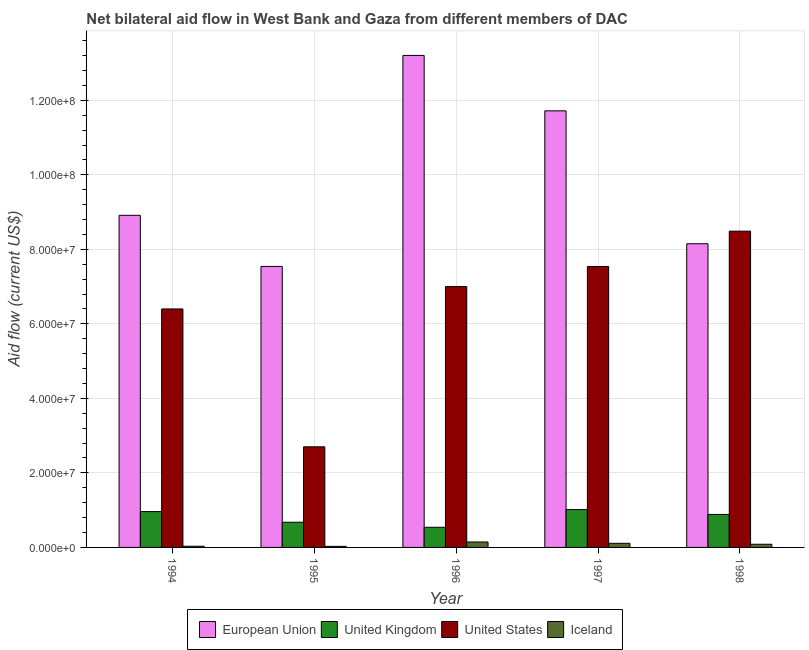How many different coloured bars are there?
Provide a succinct answer. 4. Are the number of bars per tick equal to the number of legend labels?
Keep it short and to the point. Yes. How many bars are there on the 1st tick from the right?
Provide a succinct answer. 4. In how many cases, is the number of bars for a given year not equal to the number of legend labels?
Offer a terse response. 0. What is the amount of aid given by iceland in 1996?
Provide a succinct answer. 1.46e+06. Across all years, what is the maximum amount of aid given by us?
Provide a short and direct response. 8.49e+07. Across all years, what is the minimum amount of aid given by us?
Offer a terse response. 2.70e+07. In which year was the amount of aid given by eu maximum?
Offer a terse response. 1996. In which year was the amount of aid given by us minimum?
Your answer should be very brief. 1995. What is the total amount of aid given by iceland in the graph?
Your response must be concise. 4.02e+06. What is the difference between the amount of aid given by eu in 1996 and that in 1998?
Your answer should be compact. 5.05e+07. What is the difference between the amount of aid given by uk in 1997 and the amount of aid given by us in 1994?
Your answer should be very brief. 5.40e+05. What is the average amount of aid given by eu per year?
Give a very brief answer. 9.90e+07. In the year 1994, what is the difference between the amount of aid given by uk and amount of aid given by iceland?
Provide a succinct answer. 0. What is the ratio of the amount of aid given by uk in 1994 to that in 1997?
Offer a terse response. 0.95. What is the difference between the highest and the second highest amount of aid given by eu?
Your answer should be very brief. 1.49e+07. What is the difference between the highest and the lowest amount of aid given by iceland?
Provide a short and direct response. 1.17e+06. In how many years, is the amount of aid given by us greater than the average amount of aid given by us taken over all years?
Provide a succinct answer. 3. Is it the case that in every year, the sum of the amount of aid given by us and amount of aid given by eu is greater than the sum of amount of aid given by iceland and amount of aid given by uk?
Offer a terse response. Yes. What does the 3rd bar from the left in 1995 represents?
Give a very brief answer. United States. What does the 4th bar from the right in 1995 represents?
Ensure brevity in your answer.  European Union. How many years are there in the graph?
Give a very brief answer. 5. What is the difference between two consecutive major ticks on the Y-axis?
Offer a very short reply. 2.00e+07. Are the values on the major ticks of Y-axis written in scientific E-notation?
Your answer should be very brief. Yes. Does the graph contain any zero values?
Offer a terse response. No. Does the graph contain grids?
Provide a short and direct response. Yes. Where does the legend appear in the graph?
Provide a succinct answer. Bottom center. What is the title of the graph?
Your answer should be compact. Net bilateral aid flow in West Bank and Gaza from different members of DAC. Does "Bird species" appear as one of the legend labels in the graph?
Offer a very short reply. No. What is the Aid flow (current US$) of European Union in 1994?
Provide a succinct answer. 8.91e+07. What is the Aid flow (current US$) of United Kingdom in 1994?
Keep it short and to the point. 9.62e+06. What is the Aid flow (current US$) in United States in 1994?
Provide a short and direct response. 6.40e+07. What is the Aid flow (current US$) in Iceland in 1994?
Provide a short and direct response. 3.20e+05. What is the Aid flow (current US$) of European Union in 1995?
Give a very brief answer. 7.54e+07. What is the Aid flow (current US$) of United Kingdom in 1995?
Offer a very short reply. 6.76e+06. What is the Aid flow (current US$) in United States in 1995?
Your answer should be very brief. 2.70e+07. What is the Aid flow (current US$) in European Union in 1996?
Give a very brief answer. 1.32e+08. What is the Aid flow (current US$) of United Kingdom in 1996?
Keep it short and to the point. 5.41e+06. What is the Aid flow (current US$) in United States in 1996?
Provide a short and direct response. 7.00e+07. What is the Aid flow (current US$) in Iceland in 1996?
Give a very brief answer. 1.46e+06. What is the Aid flow (current US$) in European Union in 1997?
Make the answer very short. 1.17e+08. What is the Aid flow (current US$) in United Kingdom in 1997?
Provide a succinct answer. 1.02e+07. What is the Aid flow (current US$) in United States in 1997?
Give a very brief answer. 7.54e+07. What is the Aid flow (current US$) in Iceland in 1997?
Ensure brevity in your answer.  1.10e+06. What is the Aid flow (current US$) in European Union in 1998?
Provide a succinct answer. 8.15e+07. What is the Aid flow (current US$) of United Kingdom in 1998?
Provide a short and direct response. 8.85e+06. What is the Aid flow (current US$) in United States in 1998?
Your response must be concise. 8.49e+07. What is the Aid flow (current US$) in Iceland in 1998?
Provide a short and direct response. 8.50e+05. Across all years, what is the maximum Aid flow (current US$) of European Union?
Keep it short and to the point. 1.32e+08. Across all years, what is the maximum Aid flow (current US$) in United Kingdom?
Provide a succinct answer. 1.02e+07. Across all years, what is the maximum Aid flow (current US$) in United States?
Provide a short and direct response. 8.49e+07. Across all years, what is the maximum Aid flow (current US$) in Iceland?
Keep it short and to the point. 1.46e+06. Across all years, what is the minimum Aid flow (current US$) of European Union?
Your answer should be very brief. 7.54e+07. Across all years, what is the minimum Aid flow (current US$) of United Kingdom?
Make the answer very short. 5.41e+06. Across all years, what is the minimum Aid flow (current US$) in United States?
Your answer should be very brief. 2.70e+07. What is the total Aid flow (current US$) of European Union in the graph?
Make the answer very short. 4.95e+08. What is the total Aid flow (current US$) in United Kingdom in the graph?
Make the answer very short. 4.08e+07. What is the total Aid flow (current US$) of United States in the graph?
Offer a terse response. 3.21e+08. What is the total Aid flow (current US$) of Iceland in the graph?
Your answer should be very brief. 4.02e+06. What is the difference between the Aid flow (current US$) of European Union in 1994 and that in 1995?
Offer a very short reply. 1.37e+07. What is the difference between the Aid flow (current US$) of United Kingdom in 1994 and that in 1995?
Give a very brief answer. 2.86e+06. What is the difference between the Aid flow (current US$) of United States in 1994 and that in 1995?
Provide a short and direct response. 3.70e+07. What is the difference between the Aid flow (current US$) in European Union in 1994 and that in 1996?
Your answer should be compact. -4.29e+07. What is the difference between the Aid flow (current US$) in United Kingdom in 1994 and that in 1996?
Offer a very short reply. 4.21e+06. What is the difference between the Aid flow (current US$) of United States in 1994 and that in 1996?
Your answer should be very brief. -6.00e+06. What is the difference between the Aid flow (current US$) in Iceland in 1994 and that in 1996?
Your answer should be compact. -1.14e+06. What is the difference between the Aid flow (current US$) in European Union in 1994 and that in 1997?
Keep it short and to the point. -2.80e+07. What is the difference between the Aid flow (current US$) in United Kingdom in 1994 and that in 1997?
Ensure brevity in your answer.  -5.40e+05. What is the difference between the Aid flow (current US$) in United States in 1994 and that in 1997?
Offer a terse response. -1.14e+07. What is the difference between the Aid flow (current US$) in Iceland in 1994 and that in 1997?
Provide a short and direct response. -7.80e+05. What is the difference between the Aid flow (current US$) of European Union in 1994 and that in 1998?
Your answer should be compact. 7.63e+06. What is the difference between the Aid flow (current US$) of United Kingdom in 1994 and that in 1998?
Keep it short and to the point. 7.70e+05. What is the difference between the Aid flow (current US$) in United States in 1994 and that in 1998?
Provide a short and direct response. -2.09e+07. What is the difference between the Aid flow (current US$) in Iceland in 1994 and that in 1998?
Your response must be concise. -5.30e+05. What is the difference between the Aid flow (current US$) of European Union in 1995 and that in 1996?
Offer a terse response. -5.66e+07. What is the difference between the Aid flow (current US$) in United Kingdom in 1995 and that in 1996?
Ensure brevity in your answer.  1.35e+06. What is the difference between the Aid flow (current US$) in United States in 1995 and that in 1996?
Give a very brief answer. -4.30e+07. What is the difference between the Aid flow (current US$) of Iceland in 1995 and that in 1996?
Your answer should be compact. -1.17e+06. What is the difference between the Aid flow (current US$) in European Union in 1995 and that in 1997?
Make the answer very short. -4.18e+07. What is the difference between the Aid flow (current US$) of United Kingdom in 1995 and that in 1997?
Your answer should be very brief. -3.40e+06. What is the difference between the Aid flow (current US$) of United States in 1995 and that in 1997?
Your answer should be very brief. -4.84e+07. What is the difference between the Aid flow (current US$) in Iceland in 1995 and that in 1997?
Provide a succinct answer. -8.10e+05. What is the difference between the Aid flow (current US$) of European Union in 1995 and that in 1998?
Offer a very short reply. -6.09e+06. What is the difference between the Aid flow (current US$) in United Kingdom in 1995 and that in 1998?
Make the answer very short. -2.09e+06. What is the difference between the Aid flow (current US$) of United States in 1995 and that in 1998?
Offer a very short reply. -5.79e+07. What is the difference between the Aid flow (current US$) in Iceland in 1995 and that in 1998?
Your answer should be compact. -5.60e+05. What is the difference between the Aid flow (current US$) of European Union in 1996 and that in 1997?
Give a very brief answer. 1.49e+07. What is the difference between the Aid flow (current US$) in United Kingdom in 1996 and that in 1997?
Your response must be concise. -4.75e+06. What is the difference between the Aid flow (current US$) in United States in 1996 and that in 1997?
Provide a short and direct response. -5.40e+06. What is the difference between the Aid flow (current US$) of European Union in 1996 and that in 1998?
Offer a terse response. 5.05e+07. What is the difference between the Aid flow (current US$) in United Kingdom in 1996 and that in 1998?
Offer a very short reply. -3.44e+06. What is the difference between the Aid flow (current US$) in United States in 1996 and that in 1998?
Offer a very short reply. -1.49e+07. What is the difference between the Aid flow (current US$) of Iceland in 1996 and that in 1998?
Your response must be concise. 6.10e+05. What is the difference between the Aid flow (current US$) in European Union in 1997 and that in 1998?
Your answer should be compact. 3.57e+07. What is the difference between the Aid flow (current US$) in United Kingdom in 1997 and that in 1998?
Make the answer very short. 1.31e+06. What is the difference between the Aid flow (current US$) of United States in 1997 and that in 1998?
Keep it short and to the point. -9.48e+06. What is the difference between the Aid flow (current US$) in Iceland in 1997 and that in 1998?
Provide a short and direct response. 2.50e+05. What is the difference between the Aid flow (current US$) in European Union in 1994 and the Aid flow (current US$) in United Kingdom in 1995?
Offer a terse response. 8.24e+07. What is the difference between the Aid flow (current US$) in European Union in 1994 and the Aid flow (current US$) in United States in 1995?
Your response must be concise. 6.21e+07. What is the difference between the Aid flow (current US$) of European Union in 1994 and the Aid flow (current US$) of Iceland in 1995?
Give a very brief answer. 8.88e+07. What is the difference between the Aid flow (current US$) of United Kingdom in 1994 and the Aid flow (current US$) of United States in 1995?
Offer a very short reply. -1.74e+07. What is the difference between the Aid flow (current US$) in United Kingdom in 1994 and the Aid flow (current US$) in Iceland in 1995?
Offer a very short reply. 9.33e+06. What is the difference between the Aid flow (current US$) of United States in 1994 and the Aid flow (current US$) of Iceland in 1995?
Keep it short and to the point. 6.37e+07. What is the difference between the Aid flow (current US$) of European Union in 1994 and the Aid flow (current US$) of United Kingdom in 1996?
Provide a short and direct response. 8.37e+07. What is the difference between the Aid flow (current US$) of European Union in 1994 and the Aid flow (current US$) of United States in 1996?
Keep it short and to the point. 1.91e+07. What is the difference between the Aid flow (current US$) in European Union in 1994 and the Aid flow (current US$) in Iceland in 1996?
Provide a short and direct response. 8.77e+07. What is the difference between the Aid flow (current US$) in United Kingdom in 1994 and the Aid flow (current US$) in United States in 1996?
Offer a terse response. -6.04e+07. What is the difference between the Aid flow (current US$) in United Kingdom in 1994 and the Aid flow (current US$) in Iceland in 1996?
Your answer should be very brief. 8.16e+06. What is the difference between the Aid flow (current US$) of United States in 1994 and the Aid flow (current US$) of Iceland in 1996?
Ensure brevity in your answer.  6.25e+07. What is the difference between the Aid flow (current US$) in European Union in 1994 and the Aid flow (current US$) in United Kingdom in 1997?
Your answer should be compact. 7.90e+07. What is the difference between the Aid flow (current US$) in European Union in 1994 and the Aid flow (current US$) in United States in 1997?
Make the answer very short. 1.37e+07. What is the difference between the Aid flow (current US$) of European Union in 1994 and the Aid flow (current US$) of Iceland in 1997?
Ensure brevity in your answer.  8.80e+07. What is the difference between the Aid flow (current US$) in United Kingdom in 1994 and the Aid flow (current US$) in United States in 1997?
Your response must be concise. -6.58e+07. What is the difference between the Aid flow (current US$) of United Kingdom in 1994 and the Aid flow (current US$) of Iceland in 1997?
Your answer should be compact. 8.52e+06. What is the difference between the Aid flow (current US$) of United States in 1994 and the Aid flow (current US$) of Iceland in 1997?
Offer a terse response. 6.29e+07. What is the difference between the Aid flow (current US$) in European Union in 1994 and the Aid flow (current US$) in United Kingdom in 1998?
Provide a succinct answer. 8.03e+07. What is the difference between the Aid flow (current US$) in European Union in 1994 and the Aid flow (current US$) in United States in 1998?
Offer a very short reply. 4.25e+06. What is the difference between the Aid flow (current US$) in European Union in 1994 and the Aid flow (current US$) in Iceland in 1998?
Ensure brevity in your answer.  8.83e+07. What is the difference between the Aid flow (current US$) of United Kingdom in 1994 and the Aid flow (current US$) of United States in 1998?
Make the answer very short. -7.53e+07. What is the difference between the Aid flow (current US$) in United Kingdom in 1994 and the Aid flow (current US$) in Iceland in 1998?
Give a very brief answer. 8.77e+06. What is the difference between the Aid flow (current US$) in United States in 1994 and the Aid flow (current US$) in Iceland in 1998?
Give a very brief answer. 6.32e+07. What is the difference between the Aid flow (current US$) in European Union in 1995 and the Aid flow (current US$) in United Kingdom in 1996?
Make the answer very short. 7.00e+07. What is the difference between the Aid flow (current US$) in European Union in 1995 and the Aid flow (current US$) in United States in 1996?
Your response must be concise. 5.41e+06. What is the difference between the Aid flow (current US$) in European Union in 1995 and the Aid flow (current US$) in Iceland in 1996?
Ensure brevity in your answer.  7.40e+07. What is the difference between the Aid flow (current US$) of United Kingdom in 1995 and the Aid flow (current US$) of United States in 1996?
Provide a succinct answer. -6.32e+07. What is the difference between the Aid flow (current US$) in United Kingdom in 1995 and the Aid flow (current US$) in Iceland in 1996?
Your answer should be very brief. 5.30e+06. What is the difference between the Aid flow (current US$) in United States in 1995 and the Aid flow (current US$) in Iceland in 1996?
Keep it short and to the point. 2.55e+07. What is the difference between the Aid flow (current US$) in European Union in 1995 and the Aid flow (current US$) in United Kingdom in 1997?
Keep it short and to the point. 6.52e+07. What is the difference between the Aid flow (current US$) in European Union in 1995 and the Aid flow (current US$) in Iceland in 1997?
Offer a very short reply. 7.43e+07. What is the difference between the Aid flow (current US$) in United Kingdom in 1995 and the Aid flow (current US$) in United States in 1997?
Offer a terse response. -6.86e+07. What is the difference between the Aid flow (current US$) in United Kingdom in 1995 and the Aid flow (current US$) in Iceland in 1997?
Give a very brief answer. 5.66e+06. What is the difference between the Aid flow (current US$) of United States in 1995 and the Aid flow (current US$) of Iceland in 1997?
Provide a short and direct response. 2.59e+07. What is the difference between the Aid flow (current US$) in European Union in 1995 and the Aid flow (current US$) in United Kingdom in 1998?
Your response must be concise. 6.66e+07. What is the difference between the Aid flow (current US$) in European Union in 1995 and the Aid flow (current US$) in United States in 1998?
Your answer should be compact. -9.47e+06. What is the difference between the Aid flow (current US$) in European Union in 1995 and the Aid flow (current US$) in Iceland in 1998?
Your answer should be very brief. 7.46e+07. What is the difference between the Aid flow (current US$) of United Kingdom in 1995 and the Aid flow (current US$) of United States in 1998?
Offer a terse response. -7.81e+07. What is the difference between the Aid flow (current US$) of United Kingdom in 1995 and the Aid flow (current US$) of Iceland in 1998?
Ensure brevity in your answer.  5.91e+06. What is the difference between the Aid flow (current US$) of United States in 1995 and the Aid flow (current US$) of Iceland in 1998?
Provide a succinct answer. 2.62e+07. What is the difference between the Aid flow (current US$) in European Union in 1996 and the Aid flow (current US$) in United Kingdom in 1997?
Make the answer very short. 1.22e+08. What is the difference between the Aid flow (current US$) of European Union in 1996 and the Aid flow (current US$) of United States in 1997?
Make the answer very short. 5.66e+07. What is the difference between the Aid flow (current US$) of European Union in 1996 and the Aid flow (current US$) of Iceland in 1997?
Provide a short and direct response. 1.31e+08. What is the difference between the Aid flow (current US$) of United Kingdom in 1996 and the Aid flow (current US$) of United States in 1997?
Provide a succinct answer. -7.00e+07. What is the difference between the Aid flow (current US$) in United Kingdom in 1996 and the Aid flow (current US$) in Iceland in 1997?
Offer a very short reply. 4.31e+06. What is the difference between the Aid flow (current US$) of United States in 1996 and the Aid flow (current US$) of Iceland in 1997?
Ensure brevity in your answer.  6.89e+07. What is the difference between the Aid flow (current US$) of European Union in 1996 and the Aid flow (current US$) of United Kingdom in 1998?
Give a very brief answer. 1.23e+08. What is the difference between the Aid flow (current US$) of European Union in 1996 and the Aid flow (current US$) of United States in 1998?
Provide a short and direct response. 4.72e+07. What is the difference between the Aid flow (current US$) in European Union in 1996 and the Aid flow (current US$) in Iceland in 1998?
Make the answer very short. 1.31e+08. What is the difference between the Aid flow (current US$) of United Kingdom in 1996 and the Aid flow (current US$) of United States in 1998?
Your response must be concise. -7.95e+07. What is the difference between the Aid flow (current US$) of United Kingdom in 1996 and the Aid flow (current US$) of Iceland in 1998?
Your response must be concise. 4.56e+06. What is the difference between the Aid flow (current US$) of United States in 1996 and the Aid flow (current US$) of Iceland in 1998?
Ensure brevity in your answer.  6.92e+07. What is the difference between the Aid flow (current US$) in European Union in 1997 and the Aid flow (current US$) in United Kingdom in 1998?
Keep it short and to the point. 1.08e+08. What is the difference between the Aid flow (current US$) in European Union in 1997 and the Aid flow (current US$) in United States in 1998?
Keep it short and to the point. 3.23e+07. What is the difference between the Aid flow (current US$) in European Union in 1997 and the Aid flow (current US$) in Iceland in 1998?
Provide a succinct answer. 1.16e+08. What is the difference between the Aid flow (current US$) in United Kingdom in 1997 and the Aid flow (current US$) in United States in 1998?
Provide a short and direct response. -7.47e+07. What is the difference between the Aid flow (current US$) of United Kingdom in 1997 and the Aid flow (current US$) of Iceland in 1998?
Ensure brevity in your answer.  9.31e+06. What is the difference between the Aid flow (current US$) of United States in 1997 and the Aid flow (current US$) of Iceland in 1998?
Your answer should be very brief. 7.46e+07. What is the average Aid flow (current US$) of European Union per year?
Ensure brevity in your answer.  9.90e+07. What is the average Aid flow (current US$) in United Kingdom per year?
Offer a very short reply. 8.16e+06. What is the average Aid flow (current US$) in United States per year?
Keep it short and to the point. 6.43e+07. What is the average Aid flow (current US$) in Iceland per year?
Make the answer very short. 8.04e+05. In the year 1994, what is the difference between the Aid flow (current US$) of European Union and Aid flow (current US$) of United Kingdom?
Your answer should be compact. 7.95e+07. In the year 1994, what is the difference between the Aid flow (current US$) in European Union and Aid flow (current US$) in United States?
Offer a terse response. 2.51e+07. In the year 1994, what is the difference between the Aid flow (current US$) of European Union and Aid flow (current US$) of Iceland?
Provide a succinct answer. 8.88e+07. In the year 1994, what is the difference between the Aid flow (current US$) of United Kingdom and Aid flow (current US$) of United States?
Your answer should be compact. -5.44e+07. In the year 1994, what is the difference between the Aid flow (current US$) in United Kingdom and Aid flow (current US$) in Iceland?
Your answer should be compact. 9.30e+06. In the year 1994, what is the difference between the Aid flow (current US$) in United States and Aid flow (current US$) in Iceland?
Ensure brevity in your answer.  6.37e+07. In the year 1995, what is the difference between the Aid flow (current US$) of European Union and Aid flow (current US$) of United Kingdom?
Make the answer very short. 6.86e+07. In the year 1995, what is the difference between the Aid flow (current US$) in European Union and Aid flow (current US$) in United States?
Provide a short and direct response. 4.84e+07. In the year 1995, what is the difference between the Aid flow (current US$) of European Union and Aid flow (current US$) of Iceland?
Make the answer very short. 7.51e+07. In the year 1995, what is the difference between the Aid flow (current US$) of United Kingdom and Aid flow (current US$) of United States?
Ensure brevity in your answer.  -2.02e+07. In the year 1995, what is the difference between the Aid flow (current US$) of United Kingdom and Aid flow (current US$) of Iceland?
Keep it short and to the point. 6.47e+06. In the year 1995, what is the difference between the Aid flow (current US$) of United States and Aid flow (current US$) of Iceland?
Keep it short and to the point. 2.67e+07. In the year 1996, what is the difference between the Aid flow (current US$) of European Union and Aid flow (current US$) of United Kingdom?
Offer a very short reply. 1.27e+08. In the year 1996, what is the difference between the Aid flow (current US$) in European Union and Aid flow (current US$) in United States?
Ensure brevity in your answer.  6.20e+07. In the year 1996, what is the difference between the Aid flow (current US$) in European Union and Aid flow (current US$) in Iceland?
Your answer should be very brief. 1.31e+08. In the year 1996, what is the difference between the Aid flow (current US$) of United Kingdom and Aid flow (current US$) of United States?
Ensure brevity in your answer.  -6.46e+07. In the year 1996, what is the difference between the Aid flow (current US$) of United Kingdom and Aid flow (current US$) of Iceland?
Your answer should be very brief. 3.95e+06. In the year 1996, what is the difference between the Aid flow (current US$) in United States and Aid flow (current US$) in Iceland?
Give a very brief answer. 6.85e+07. In the year 1997, what is the difference between the Aid flow (current US$) of European Union and Aid flow (current US$) of United Kingdom?
Make the answer very short. 1.07e+08. In the year 1997, what is the difference between the Aid flow (current US$) in European Union and Aid flow (current US$) in United States?
Make the answer very short. 4.18e+07. In the year 1997, what is the difference between the Aid flow (current US$) of European Union and Aid flow (current US$) of Iceland?
Ensure brevity in your answer.  1.16e+08. In the year 1997, what is the difference between the Aid flow (current US$) in United Kingdom and Aid flow (current US$) in United States?
Provide a succinct answer. -6.52e+07. In the year 1997, what is the difference between the Aid flow (current US$) in United Kingdom and Aid flow (current US$) in Iceland?
Offer a terse response. 9.06e+06. In the year 1997, what is the difference between the Aid flow (current US$) of United States and Aid flow (current US$) of Iceland?
Ensure brevity in your answer.  7.43e+07. In the year 1998, what is the difference between the Aid flow (current US$) in European Union and Aid flow (current US$) in United Kingdom?
Your answer should be very brief. 7.26e+07. In the year 1998, what is the difference between the Aid flow (current US$) in European Union and Aid flow (current US$) in United States?
Keep it short and to the point. -3.38e+06. In the year 1998, what is the difference between the Aid flow (current US$) of European Union and Aid flow (current US$) of Iceland?
Ensure brevity in your answer.  8.06e+07. In the year 1998, what is the difference between the Aid flow (current US$) of United Kingdom and Aid flow (current US$) of United States?
Offer a very short reply. -7.60e+07. In the year 1998, what is the difference between the Aid flow (current US$) of United States and Aid flow (current US$) of Iceland?
Keep it short and to the point. 8.40e+07. What is the ratio of the Aid flow (current US$) in European Union in 1994 to that in 1995?
Ensure brevity in your answer.  1.18. What is the ratio of the Aid flow (current US$) in United Kingdom in 1994 to that in 1995?
Make the answer very short. 1.42. What is the ratio of the Aid flow (current US$) of United States in 1994 to that in 1995?
Keep it short and to the point. 2.37. What is the ratio of the Aid flow (current US$) in Iceland in 1994 to that in 1995?
Provide a short and direct response. 1.1. What is the ratio of the Aid flow (current US$) in European Union in 1994 to that in 1996?
Offer a terse response. 0.68. What is the ratio of the Aid flow (current US$) of United Kingdom in 1994 to that in 1996?
Ensure brevity in your answer.  1.78. What is the ratio of the Aid flow (current US$) in United States in 1994 to that in 1996?
Keep it short and to the point. 0.91. What is the ratio of the Aid flow (current US$) in Iceland in 1994 to that in 1996?
Offer a very short reply. 0.22. What is the ratio of the Aid flow (current US$) of European Union in 1994 to that in 1997?
Your response must be concise. 0.76. What is the ratio of the Aid flow (current US$) of United Kingdom in 1994 to that in 1997?
Make the answer very short. 0.95. What is the ratio of the Aid flow (current US$) in United States in 1994 to that in 1997?
Offer a terse response. 0.85. What is the ratio of the Aid flow (current US$) in Iceland in 1994 to that in 1997?
Keep it short and to the point. 0.29. What is the ratio of the Aid flow (current US$) of European Union in 1994 to that in 1998?
Offer a terse response. 1.09. What is the ratio of the Aid flow (current US$) in United Kingdom in 1994 to that in 1998?
Make the answer very short. 1.09. What is the ratio of the Aid flow (current US$) of United States in 1994 to that in 1998?
Give a very brief answer. 0.75. What is the ratio of the Aid flow (current US$) of Iceland in 1994 to that in 1998?
Offer a very short reply. 0.38. What is the ratio of the Aid flow (current US$) in European Union in 1995 to that in 1996?
Ensure brevity in your answer.  0.57. What is the ratio of the Aid flow (current US$) of United Kingdom in 1995 to that in 1996?
Your answer should be very brief. 1.25. What is the ratio of the Aid flow (current US$) in United States in 1995 to that in 1996?
Provide a short and direct response. 0.39. What is the ratio of the Aid flow (current US$) of Iceland in 1995 to that in 1996?
Keep it short and to the point. 0.2. What is the ratio of the Aid flow (current US$) of European Union in 1995 to that in 1997?
Provide a short and direct response. 0.64. What is the ratio of the Aid flow (current US$) of United Kingdom in 1995 to that in 1997?
Provide a short and direct response. 0.67. What is the ratio of the Aid flow (current US$) of United States in 1995 to that in 1997?
Provide a succinct answer. 0.36. What is the ratio of the Aid flow (current US$) in Iceland in 1995 to that in 1997?
Provide a short and direct response. 0.26. What is the ratio of the Aid flow (current US$) in European Union in 1995 to that in 1998?
Ensure brevity in your answer.  0.93. What is the ratio of the Aid flow (current US$) of United Kingdom in 1995 to that in 1998?
Provide a short and direct response. 0.76. What is the ratio of the Aid flow (current US$) in United States in 1995 to that in 1998?
Offer a very short reply. 0.32. What is the ratio of the Aid flow (current US$) of Iceland in 1995 to that in 1998?
Offer a very short reply. 0.34. What is the ratio of the Aid flow (current US$) in European Union in 1996 to that in 1997?
Provide a short and direct response. 1.13. What is the ratio of the Aid flow (current US$) in United Kingdom in 1996 to that in 1997?
Provide a succinct answer. 0.53. What is the ratio of the Aid flow (current US$) in United States in 1996 to that in 1997?
Keep it short and to the point. 0.93. What is the ratio of the Aid flow (current US$) in Iceland in 1996 to that in 1997?
Give a very brief answer. 1.33. What is the ratio of the Aid flow (current US$) of European Union in 1996 to that in 1998?
Offer a terse response. 1.62. What is the ratio of the Aid flow (current US$) in United Kingdom in 1996 to that in 1998?
Offer a very short reply. 0.61. What is the ratio of the Aid flow (current US$) of United States in 1996 to that in 1998?
Offer a terse response. 0.82. What is the ratio of the Aid flow (current US$) of Iceland in 1996 to that in 1998?
Ensure brevity in your answer.  1.72. What is the ratio of the Aid flow (current US$) of European Union in 1997 to that in 1998?
Offer a very short reply. 1.44. What is the ratio of the Aid flow (current US$) of United Kingdom in 1997 to that in 1998?
Your answer should be very brief. 1.15. What is the ratio of the Aid flow (current US$) of United States in 1997 to that in 1998?
Offer a very short reply. 0.89. What is the ratio of the Aid flow (current US$) of Iceland in 1997 to that in 1998?
Make the answer very short. 1.29. What is the difference between the highest and the second highest Aid flow (current US$) in European Union?
Give a very brief answer. 1.49e+07. What is the difference between the highest and the second highest Aid flow (current US$) of United Kingdom?
Keep it short and to the point. 5.40e+05. What is the difference between the highest and the second highest Aid flow (current US$) of United States?
Make the answer very short. 9.48e+06. What is the difference between the highest and the second highest Aid flow (current US$) of Iceland?
Give a very brief answer. 3.60e+05. What is the difference between the highest and the lowest Aid flow (current US$) of European Union?
Give a very brief answer. 5.66e+07. What is the difference between the highest and the lowest Aid flow (current US$) in United Kingdom?
Provide a succinct answer. 4.75e+06. What is the difference between the highest and the lowest Aid flow (current US$) in United States?
Offer a terse response. 5.79e+07. What is the difference between the highest and the lowest Aid flow (current US$) of Iceland?
Offer a very short reply. 1.17e+06. 